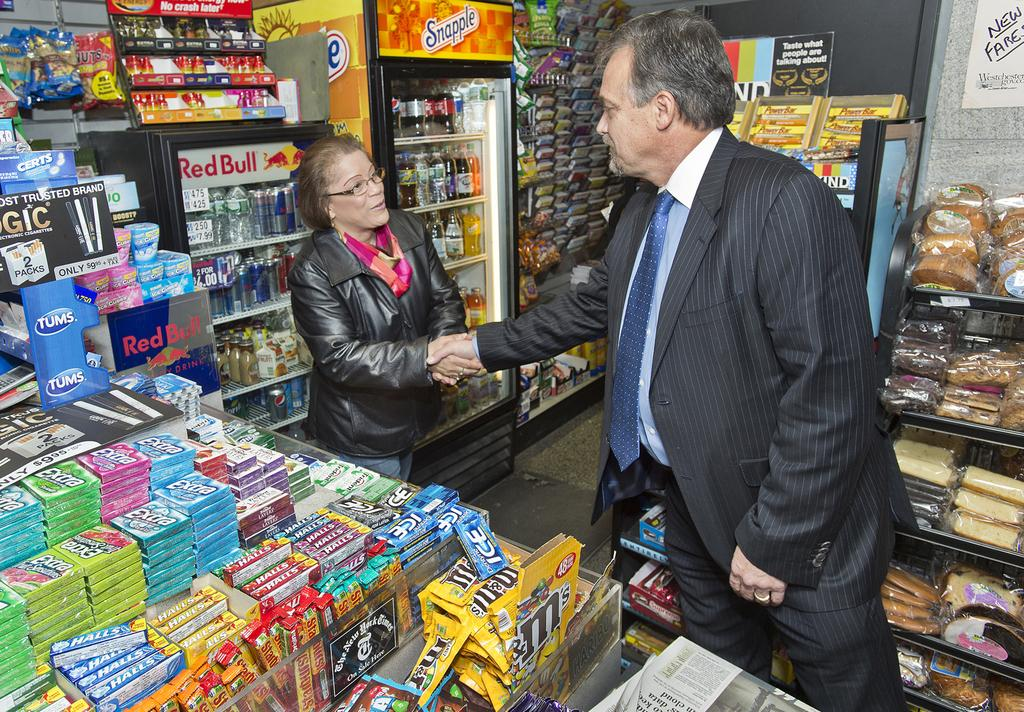<image>
Describe the image concisely. A snapple drink machine sits in a convenient store. 